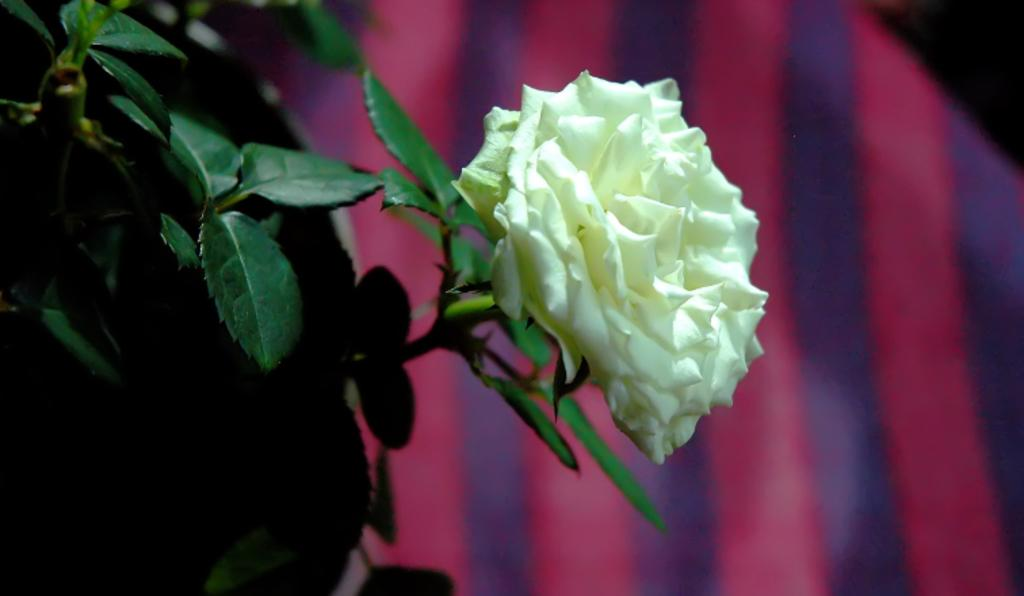What is the main subject of the image? The main subject of the image is a flower on a plant. Where is the flower located in relation to the image? The flower is in the center of the image. What type of brass instrument can be seen playing alongside the flower in the image? There is no brass instrument or any musical instrument present in the image; it only features a flower on a plant. 